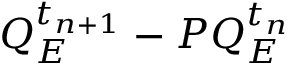Convert formula to latex. <formula><loc_0><loc_0><loc_500><loc_500>Q _ { E } ^ { t _ { n + 1 } } - P Q _ { E } ^ { t _ { n } }</formula> 